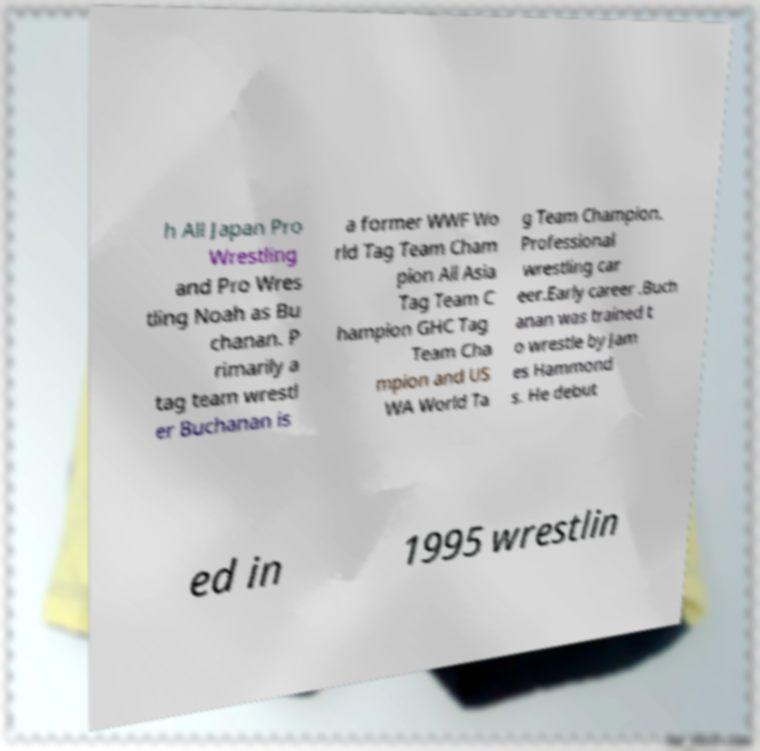For documentation purposes, I need the text within this image transcribed. Could you provide that? h All Japan Pro Wrestling and Pro Wres tling Noah as Bu chanan. P rimarily a tag team wrestl er Buchanan is a former WWF Wo rld Tag Team Cham pion All Asia Tag Team C hampion GHC Tag Team Cha mpion and US WA World Ta g Team Champion. Professional wrestling car eer.Early career .Buch anan was trained t o wrestle by Jam es Hammond s. He debut ed in 1995 wrestlin 